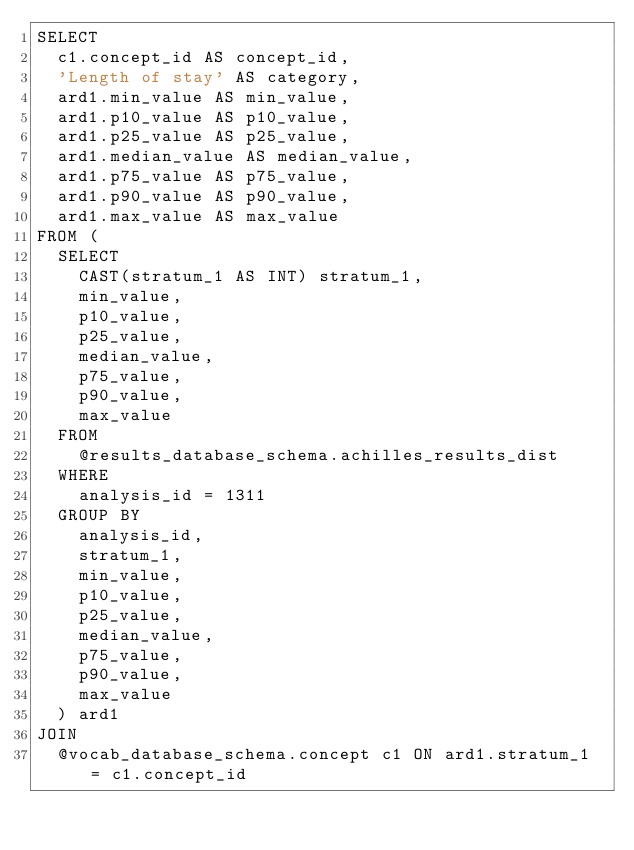Convert code to text. <code><loc_0><loc_0><loc_500><loc_500><_SQL_>SELECT 
	c1.concept_id AS concept_id,
	'Length of stay' AS category,
	ard1.min_value AS min_value,
	ard1.p10_value AS p10_value,
	ard1.p25_value AS p25_value,
	ard1.median_value AS median_value,
	ard1.p75_value AS p75_value,
	ard1.p90_value AS p90_value,
	ard1.max_value AS max_value
FROM (
	SELECT 
		CAST(stratum_1 AS INT) stratum_1,
		min_value,
		p10_value,
		p25_value,
		median_value,
		p75_value,
		p90_value,
		max_value
	FROM 
		@results_database_schema.achilles_results_dist
	WHERE 
		analysis_id = 1311
	GROUP BY 
		analysis_id,
		stratum_1,
		min_value,
		p10_value,
		p25_value,
		median_value,
		p75_value,
		p90_value,
		max_value
	) ard1
JOIN 
	@vocab_database_schema.concept c1 ON ard1.stratum_1 = c1.concept_id
</code> 